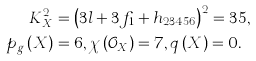<formula> <loc_0><loc_0><loc_500><loc_500>K _ { X } ^ { 2 } & = \left ( 3 l + 3 f _ { 1 } + h _ { 2 3 4 5 6 } \right ) ^ { 2 } = 3 5 , \\ p _ { g } \left ( X \right ) & = 6 , \chi \left ( \mathcal { O } _ { X } \right ) = 7 , q \left ( X \right ) = 0 .</formula> 